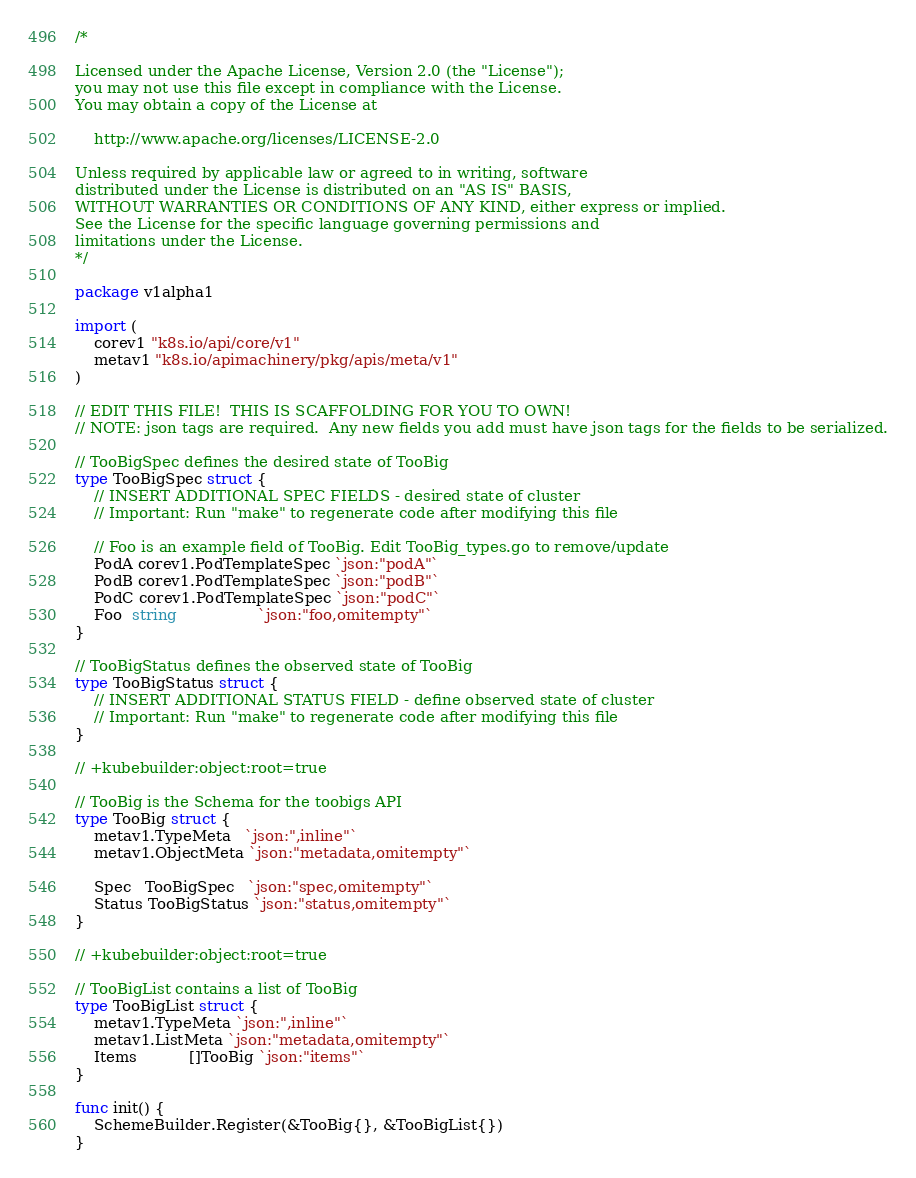<code> <loc_0><loc_0><loc_500><loc_500><_Go_>/*

Licensed under the Apache License, Version 2.0 (the "License");
you may not use this file except in compliance with the License.
You may obtain a copy of the License at

    http://www.apache.org/licenses/LICENSE-2.0

Unless required by applicable law or agreed to in writing, software
distributed under the License is distributed on an "AS IS" BASIS,
WITHOUT WARRANTIES OR CONDITIONS OF ANY KIND, either express or implied.
See the License for the specific language governing permissions and
limitations under the License.
*/

package v1alpha1

import (
	corev1 "k8s.io/api/core/v1"
	metav1 "k8s.io/apimachinery/pkg/apis/meta/v1"
)

// EDIT THIS FILE!  THIS IS SCAFFOLDING FOR YOU TO OWN!
// NOTE: json tags are required.  Any new fields you add must have json tags for the fields to be serialized.

// TooBigSpec defines the desired state of TooBig
type TooBigSpec struct {
	// INSERT ADDITIONAL SPEC FIELDS - desired state of cluster
	// Important: Run "make" to regenerate code after modifying this file

	// Foo is an example field of TooBig. Edit TooBig_types.go to remove/update
	PodA corev1.PodTemplateSpec `json:"podA"`
	PodB corev1.PodTemplateSpec `json:"podB"`
	PodC corev1.PodTemplateSpec `json:"podC"`
	Foo  string                 `json:"foo,omitempty"`
}

// TooBigStatus defines the observed state of TooBig
type TooBigStatus struct {
	// INSERT ADDITIONAL STATUS FIELD - define observed state of cluster
	// Important: Run "make" to regenerate code after modifying this file
}

// +kubebuilder:object:root=true

// TooBig is the Schema for the toobigs API
type TooBig struct {
	metav1.TypeMeta   `json:",inline"`
	metav1.ObjectMeta `json:"metadata,omitempty"`

	Spec   TooBigSpec   `json:"spec,omitempty"`
	Status TooBigStatus `json:"status,omitempty"`
}

// +kubebuilder:object:root=true

// TooBigList contains a list of TooBig
type TooBigList struct {
	metav1.TypeMeta `json:",inline"`
	metav1.ListMeta `json:"metadata,omitempty"`
	Items           []TooBig `json:"items"`
}

func init() {
	SchemeBuilder.Register(&TooBig{}, &TooBigList{})
}
</code> 